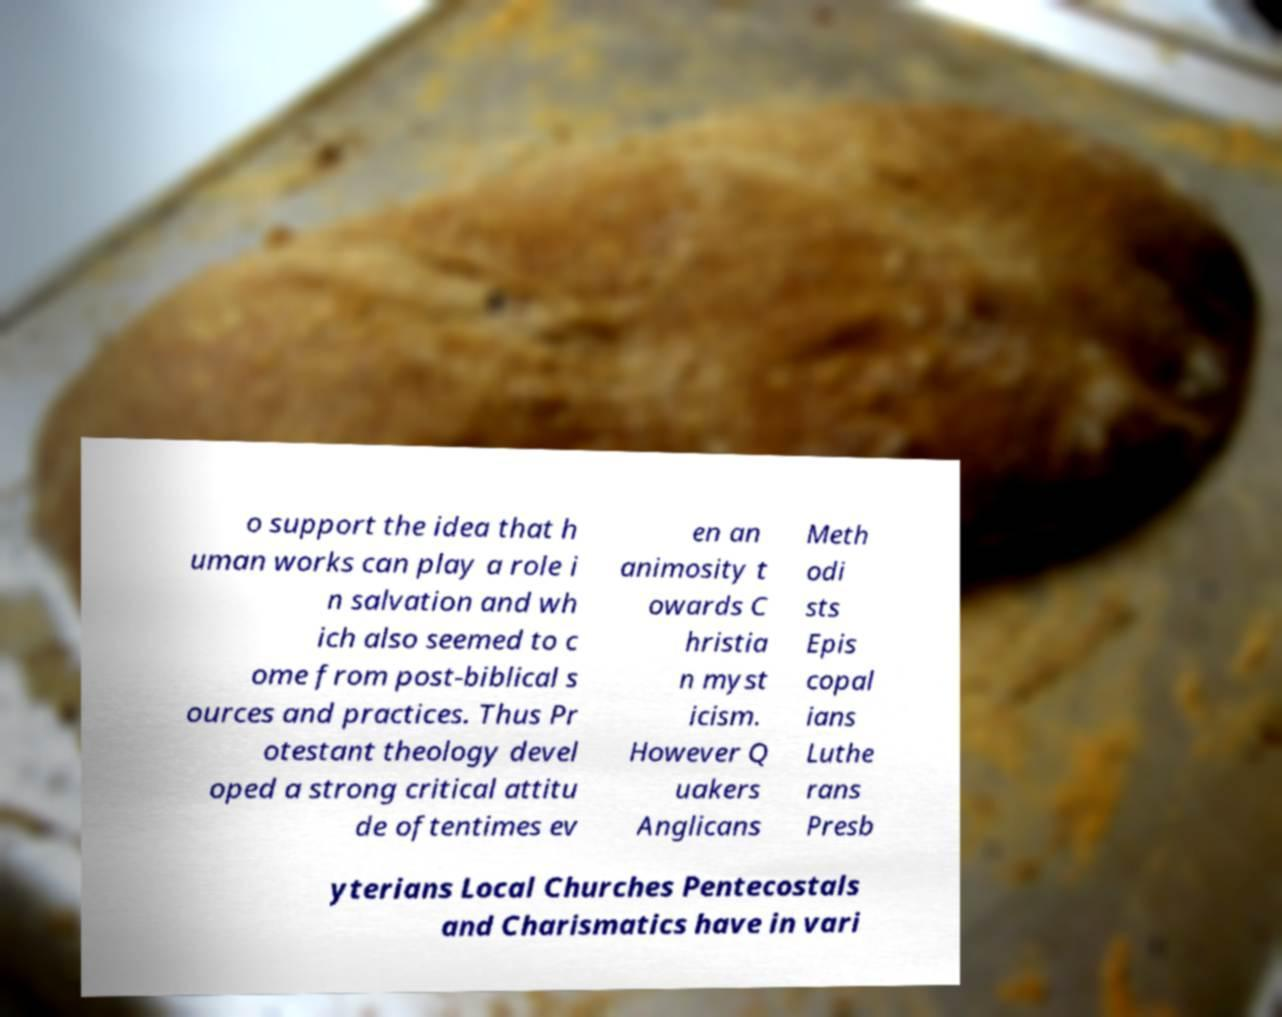Could you extract and type out the text from this image? o support the idea that h uman works can play a role i n salvation and wh ich also seemed to c ome from post-biblical s ources and practices. Thus Pr otestant theology devel oped a strong critical attitu de oftentimes ev en an animosity t owards C hristia n myst icism. However Q uakers Anglicans Meth odi sts Epis copal ians Luthe rans Presb yterians Local Churches Pentecostals and Charismatics have in vari 